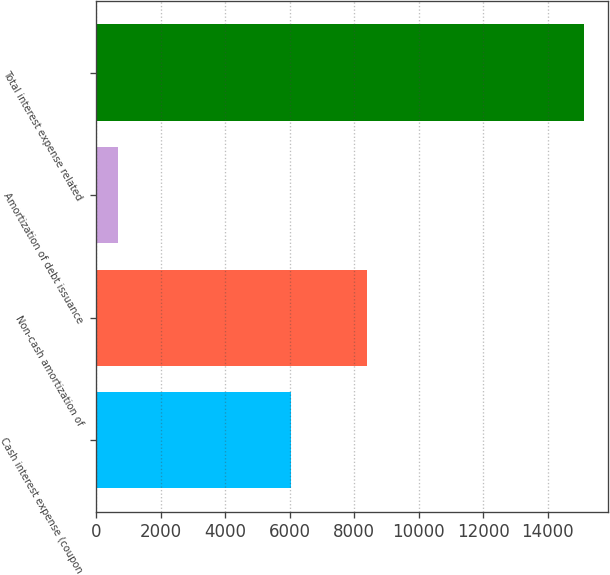<chart> <loc_0><loc_0><loc_500><loc_500><bar_chart><fcel>Cash interest expense (coupon<fcel>Non-cash amortization of<fcel>Amortization of debt issuance<fcel>Total interest expense related<nl><fcel>6038<fcel>8392<fcel>682<fcel>15112<nl></chart> 